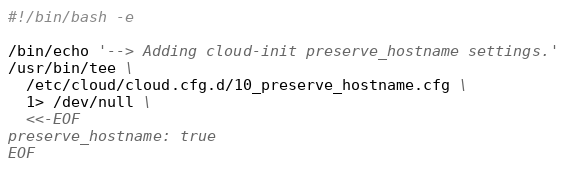<code> <loc_0><loc_0><loc_500><loc_500><_Bash_>#!/bin/bash -e

/bin/echo '--> Adding cloud-init preserve_hostname settings.'
/usr/bin/tee \
  /etc/cloud/cloud.cfg.d/10_preserve_hostname.cfg \
  1> /dev/null \
  <<-EOF
preserve_hostname: true
EOF

</code> 